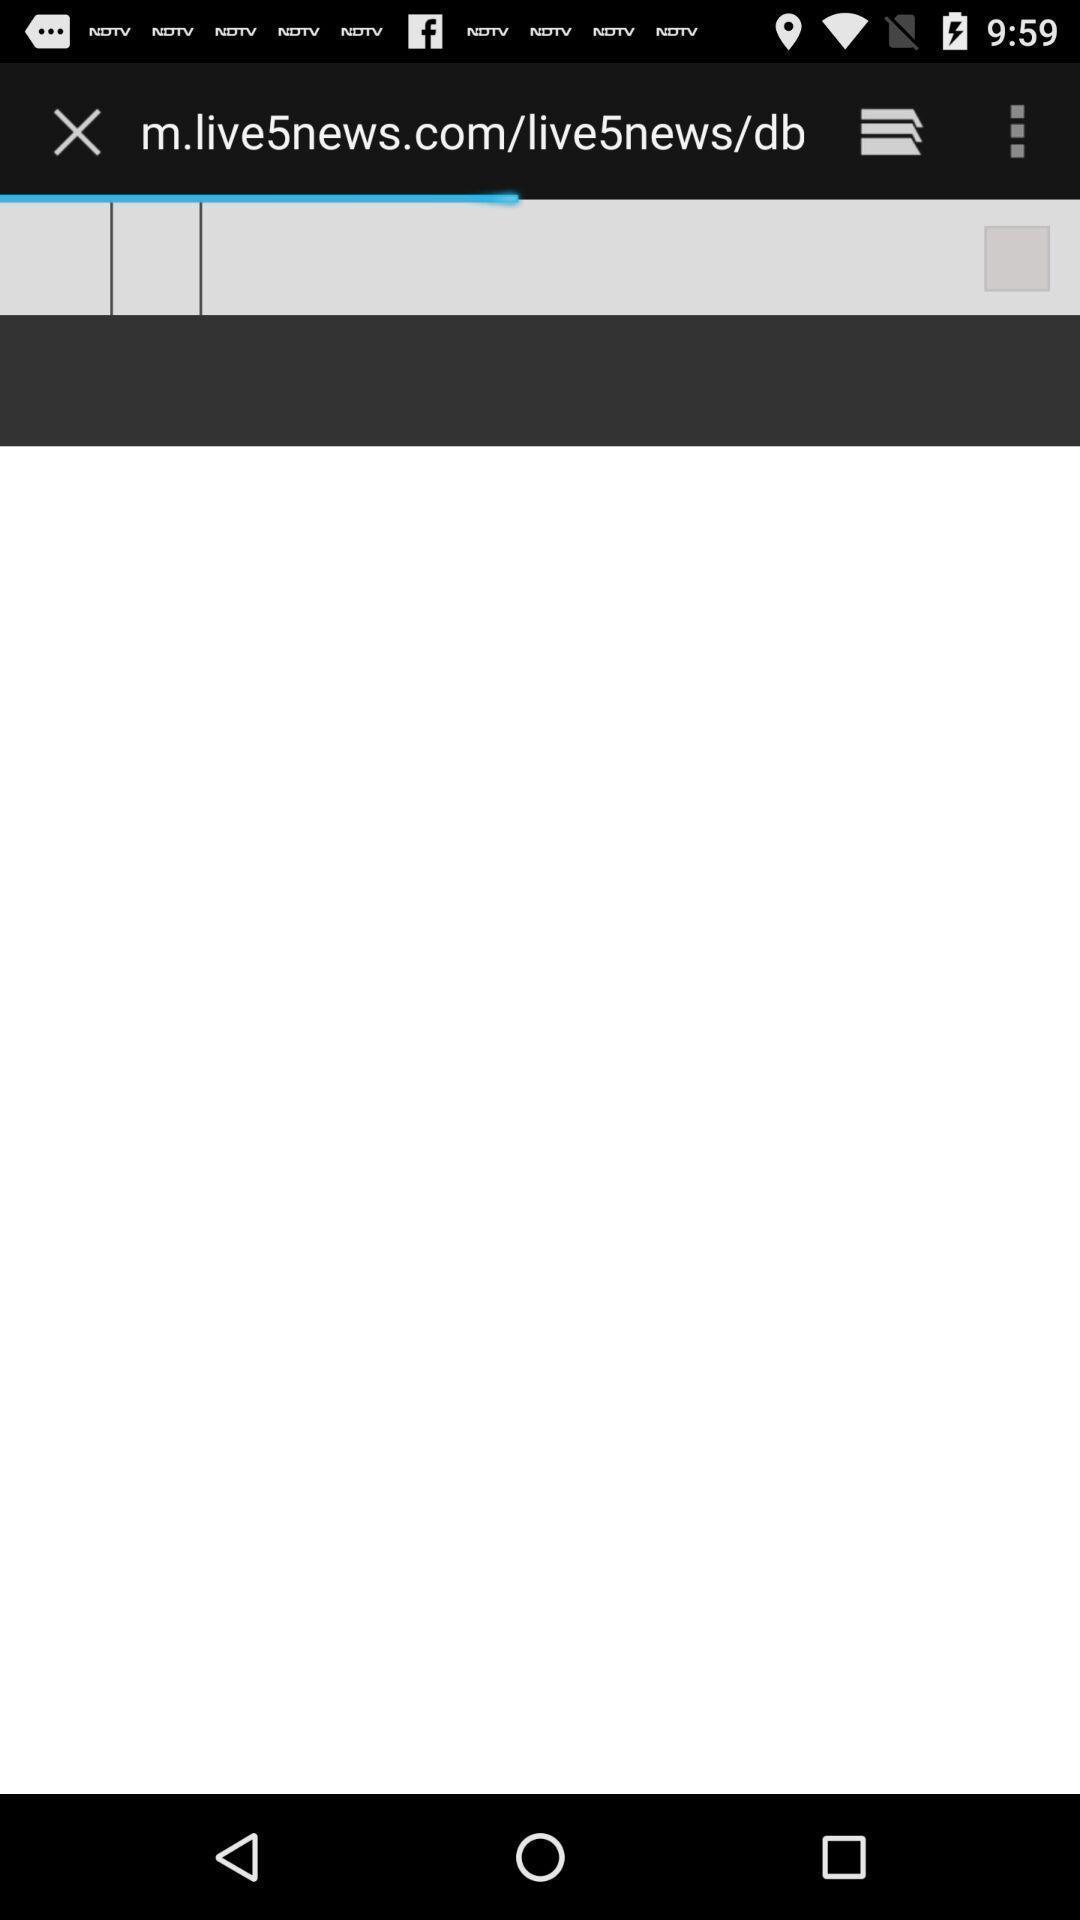Describe the content in this image. Page of a news website. 